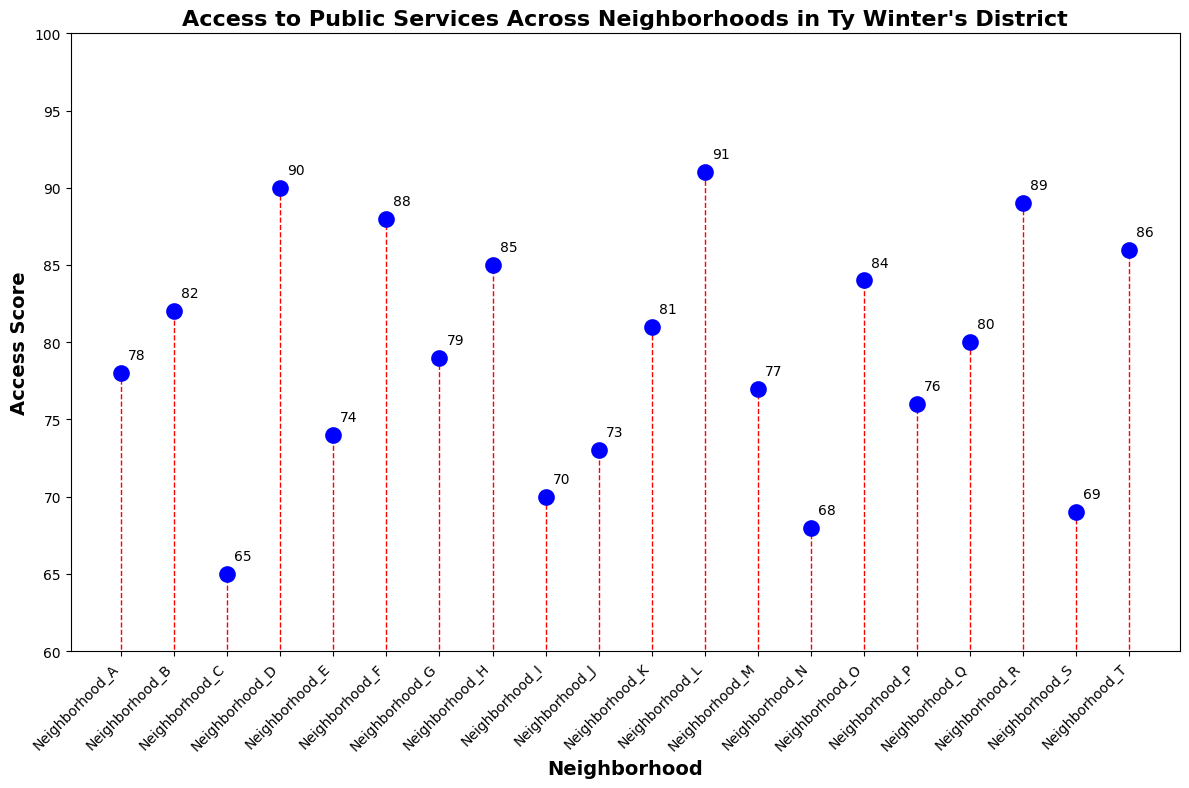Which neighborhood has the highest Access Score? By looking at the figure, the highest point on the stem plot represents the highest Access Score. The score of 91 corresponds to Neighborhood_L.
Answer: Neighborhood_L Which neighborhood has the lowest Access Score? The lowest point on the stem plot represents the lowest Access Score. The score of 65 corresponds to Neighborhood_C.
Answer: Neighborhood_C What is the average Access Score across all neighborhoods? To calculate the average Access Score, sum all the scores and divide by the number of neighborhoods. The sum is 78 + 82 + 65 + 90 + 74 + 88 + 79 + 85 + 70 + 73 + 81 + 91 + 77 + 68 + 84 + 76 + 80 + 89 + 69 + 86 = 1585. There are 20 neighborhoods, so 1585/20 = 79.25.
Answer: 79.25 Which neighborhoods have an Access Score greater than 85? Identify all neighborhoods with markers above the Access Score of 85. These neighborhoods are Neighborhood_D, Neighborhood_F, Neighborhood_H, Neighborhood_L, Neighborhood_R, and Neighborhood_T.
Answer: Neighborhood_D, Neighborhood_F, Neighborhood_H, Neighborhood_L, Neighborhood_R, Neighborhood_T What is the difference in Access Score between Neighborhood_B and Neighborhood_I? Subtract the Access Score of Neighborhood_I from Neighborhood_B. The scores are 82 and 70, respectively. So, 82 - 70 = 12.
Answer: 12 How many neighborhoods have an Access Score below the district's average? The average Access Score is 79.25. Count the neighborhoods with scores below this average: Neighborhood_C, Neighborhood_E, Neighborhood_I, Neighborhood_J, Neighborhood_M, Neighborhood_N, Neighborhood_P, Neighborhood_S. There are 8 such neighborhoods.
Answer: 8 Which neighborhoods have an Access Score exactly equal to 85? Look for the neighborhoods precisely at the Access Score of 85. This score corresponds to Neighborhood_H.
Answer: Neighborhood_H What is the difference between the highest and lowest Access Scores? Subtract the lowest Access Score from the highest Access Score. The highest is 91, and the lowest is 65, so 91 - 65 = 26.
Answer: 26 Is the Access Score of Neighborhood_K closer to that of Neighborhood_G or Neighborhood_Q? Compare the difference between Neighborhood_K's score with Neighborhood_G and Neighborhood_Q. Scores: K = 81, G = 79, Q = 80. The difference with G is 81 - 79 = 2, and the difference with Q is 81 - 80 = 1. So, it is closer to Neighborhood_Q.
Answer: Neighborhood_Q 